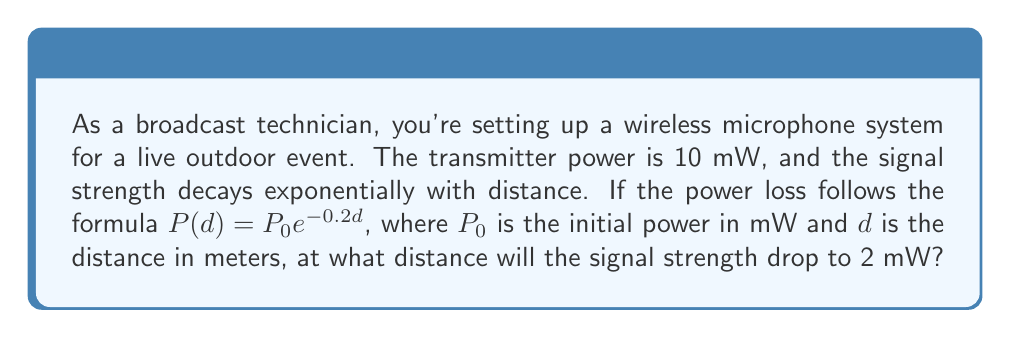Help me with this question. To solve this problem, we'll use the exponential decay formula provided and solve for the distance $d$. Let's break it down step-by-step:

1) The given formula is:
   $$P(d) = P_0 e^{-0.2d}$$

2) We know:
   - Initial power $P_0 = 10$ mW
   - We want to find $d$ when $P(d) = 2$ mW

3) Let's substitute these values into the equation:
   $$2 = 10 e^{-0.2d}$$

4) Divide both sides by 10:
   $$\frac{2}{10} = e^{-0.2d}$$
   $$0.2 = e^{-0.2d}$$

5) Take the natural logarithm of both sides:
   $$\ln(0.2) = \ln(e^{-0.2d})$$
   $$\ln(0.2) = -0.2d$$

6) Divide both sides by -0.2:
   $$\frac{\ln(0.2)}{-0.2} = d$$

7) Calculate the value:
   $$d = -\frac{\ln(0.2)}{0.2} \approx 8.05$$

Therefore, the signal strength will drop to 2 mW at approximately 8.05 meters from the transmitter.
Answer: 8.05 meters 